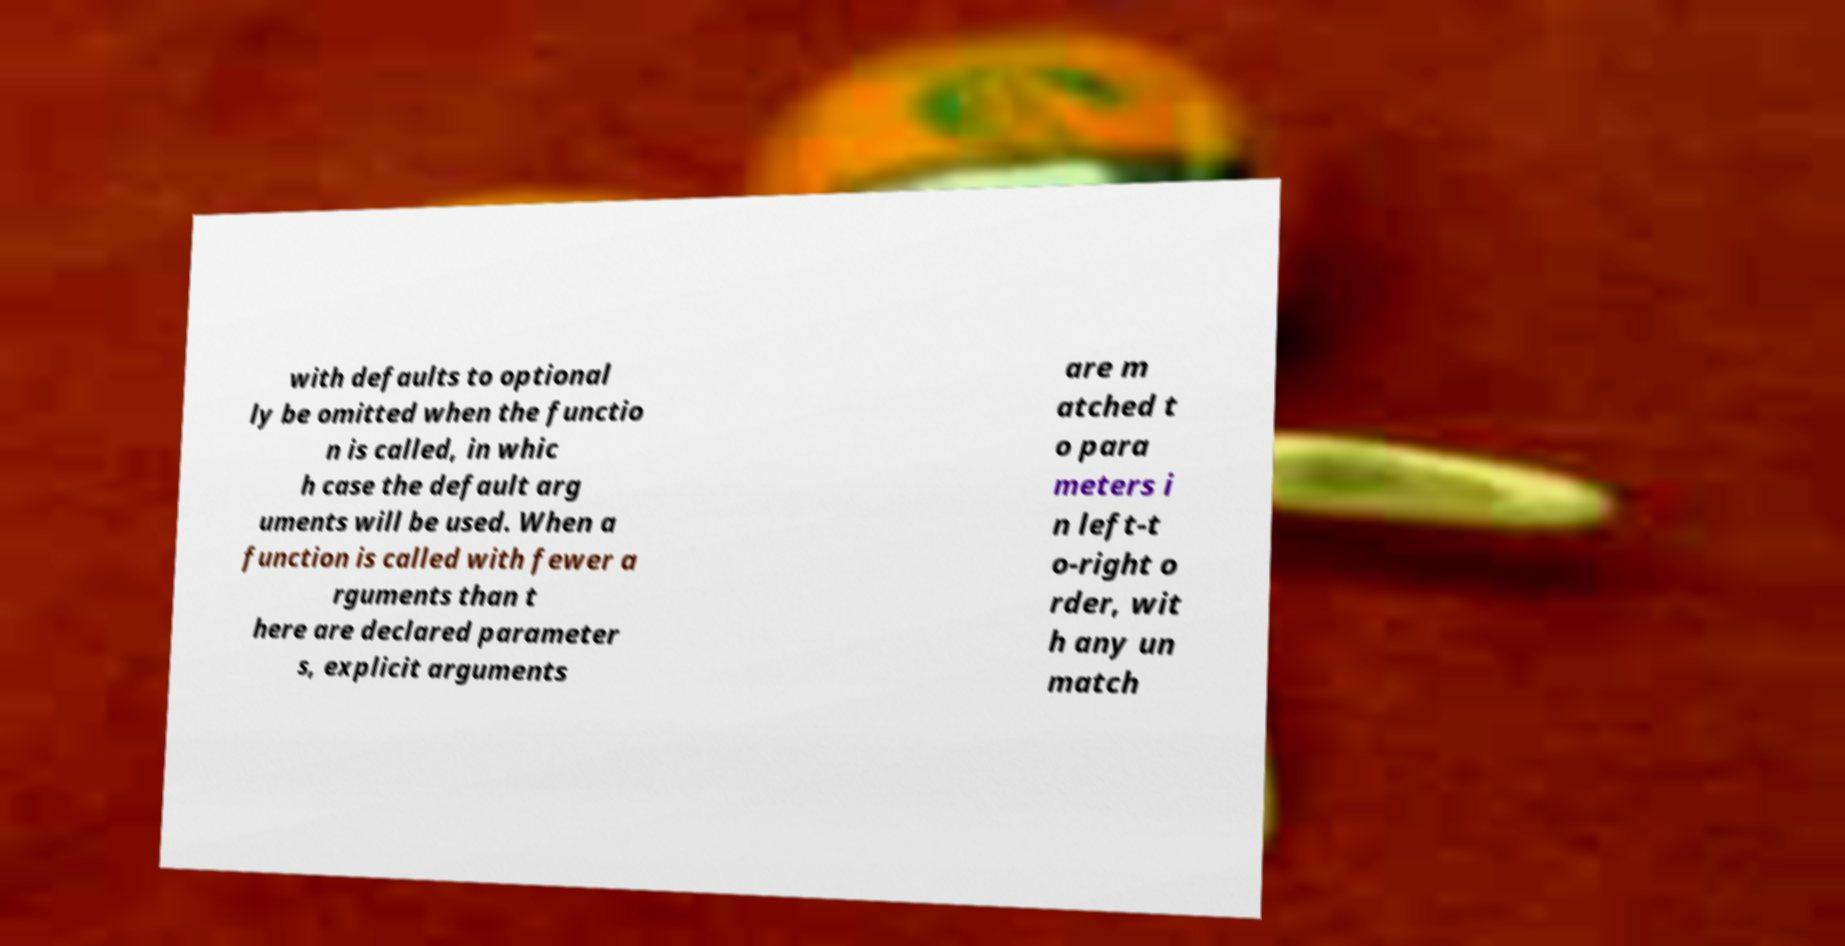There's text embedded in this image that I need extracted. Can you transcribe it verbatim? with defaults to optional ly be omitted when the functio n is called, in whic h case the default arg uments will be used. When a function is called with fewer a rguments than t here are declared parameter s, explicit arguments are m atched t o para meters i n left-t o-right o rder, wit h any un match 